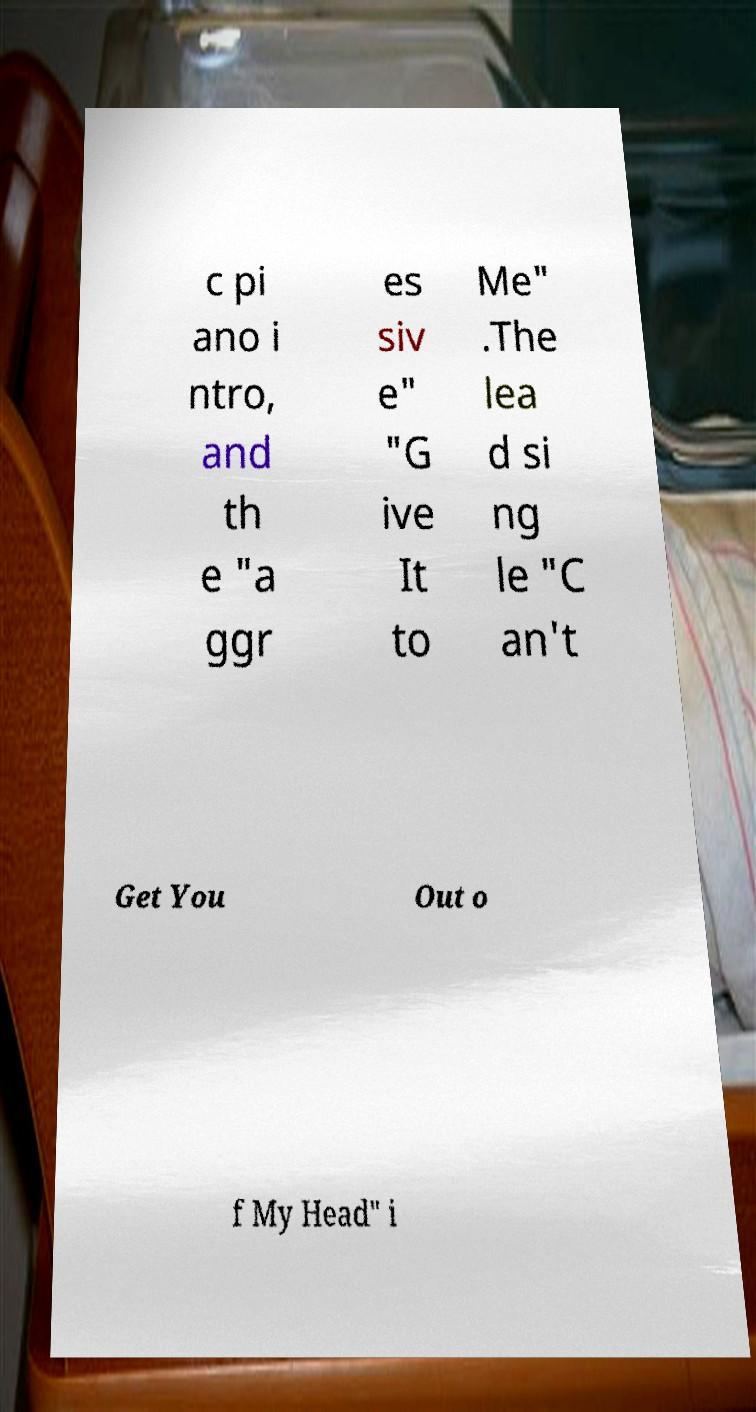Can you read and provide the text displayed in the image?This photo seems to have some interesting text. Can you extract and type it out for me? c pi ano i ntro, and th e "a ggr es siv e" "G ive It to Me" .The lea d si ng le "C an't Get You Out o f My Head" i 